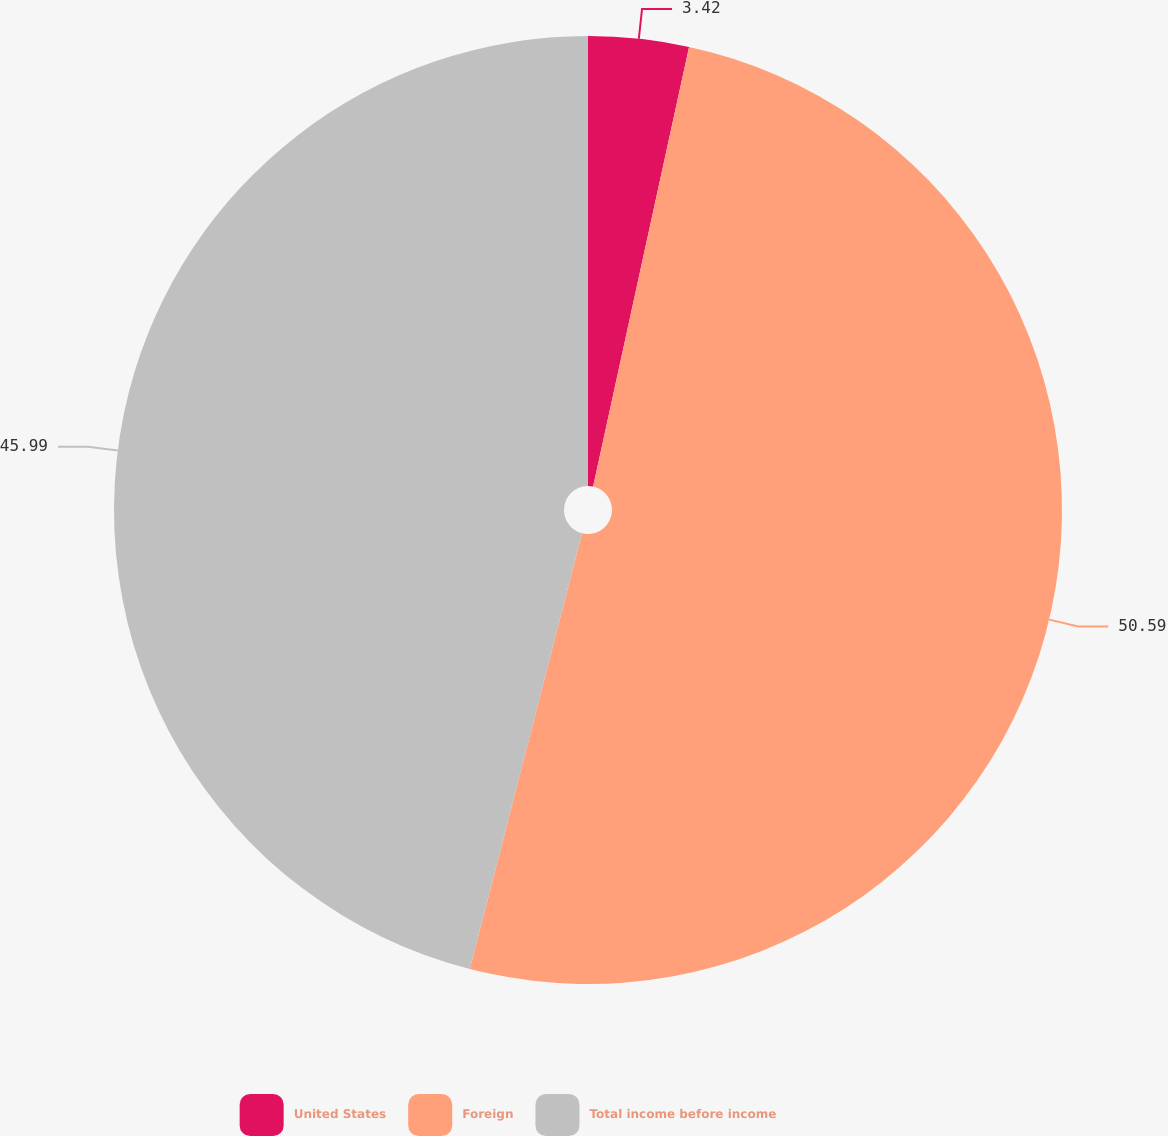Convert chart to OTSL. <chart><loc_0><loc_0><loc_500><loc_500><pie_chart><fcel>United States<fcel>Foreign<fcel>Total income before income<nl><fcel>3.42%<fcel>50.59%<fcel>45.99%<nl></chart> 